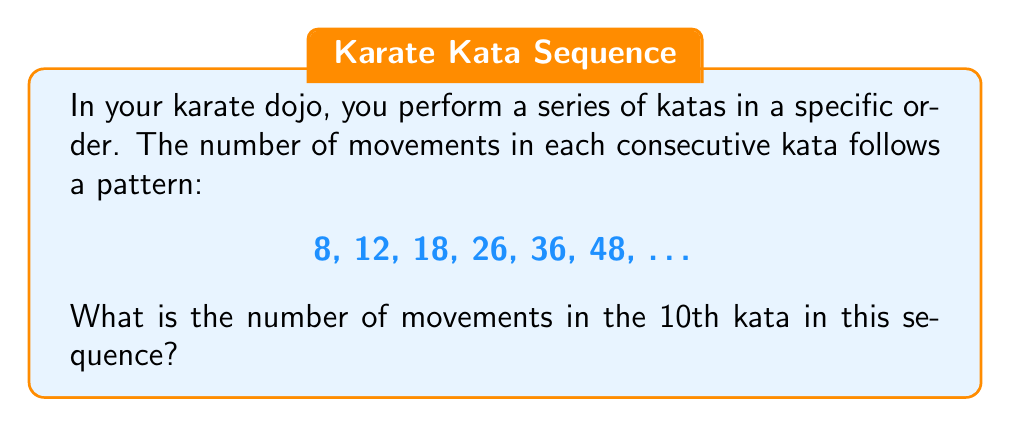Give your solution to this math problem. Let's analyze the pattern step-by-step:

1) First, calculate the differences between consecutive terms:
   12 - 8 = 4
   18 - 12 = 6
   26 - 18 = 8
   36 - 26 = 10
   48 - 36 = 12

2) We can see that the differences form an arithmetic sequence: 4, 6, 8, 10, 12, ...
   The difference between these differences is constant: 2

3) We can express this as a quadratic sequence. The general form of a quadratic sequence is:
   $$a_n = an^2 + bn + c$$
   where $n$ is the term number (starting from 0), and $a$, $b$, and $c$ are constants.

4) To find $a$, we use the second difference (which is constant in a quadratic sequence):
   $$a = \frac{1}{2} \times 2 = 1$$

5) Now we can set up a system of equations using the first two terms:
   $$8 = c$$
   $$12 = a + b + c = 1 + b + 8$$

6) Solving this, we get:
   $$c = 8$$
   $$b = 3$$

7) Therefore, our sequence follows the formula:
   $$a_n = n^2 + 3n + 8$$

8) To find the 10th term, we substitute $n = 9$ (since we start counting from 0):
   $$a_9 = 9^2 + 3(9) + 8 = 81 + 27 + 8 = 116$$
Answer: 116 